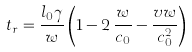<formula> <loc_0><loc_0><loc_500><loc_500>t _ { r } = \frac { l _ { 0 } \gamma } { w } \left ( 1 - 2 \, \frac { w } { c _ { 0 } } - \frac { v w } { c _ { 0 } ^ { 2 } } \right )</formula> 